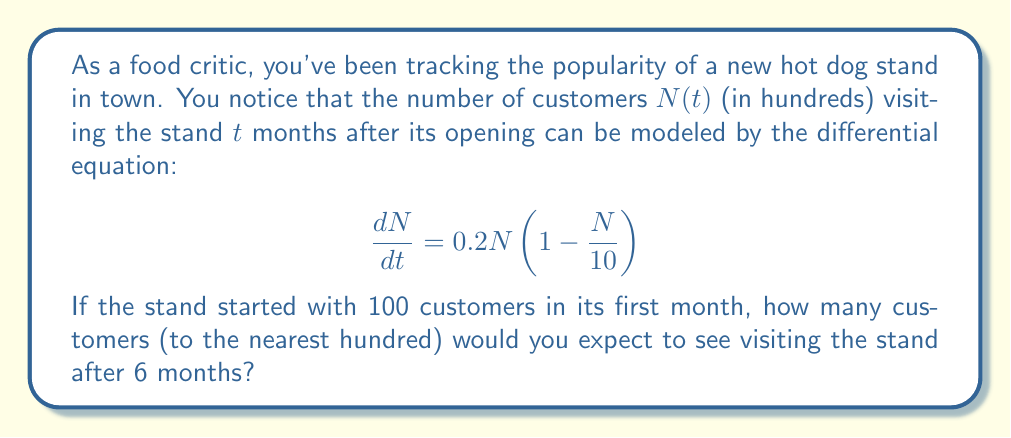Can you answer this question? To solve this problem, we need to recognize that this is a logistic growth model for population dynamics. Let's break it down step-by-step:

1) The given differential equation is:

   $$\frac{dN}{dt} = 0.2N(1 - \frac{N}{10})$$

   This is the standard form of the logistic equation, where:
   - $0.2$ is the growth rate
   - $10$ (in hundreds, so 1000) is the carrying capacity

2) The general solution to the logistic equation is:

   $$N(t) = \frac{K}{1 + (\frac{K}{N_0} - 1)e^{-rt}}$$

   Where:
   - $K$ is the carrying capacity (10 in our case)
   - $N_0$ is the initial population
   - $r$ is the growth rate (0.2 in our case)

3) We're given that the initial population $N_0 = 1$ (100 customers)

4) Plugging in our values:

   $$N(t) = \frac{10}{1 + (10 - 1)e^{-0.2t}}$$

5) We want to find $N(6)$, so let's substitute $t = 6$:

   $$N(6) = \frac{10}{1 + 9e^{-1.2}}$$

6) Calculating this:
   
   $$N(6) \approx 5.85$$

7) Remember, $N$ is in hundreds, so this represents about 585 customers.

8) Rounding to the nearest hundred gives us 600 customers.
Answer: 600 customers 